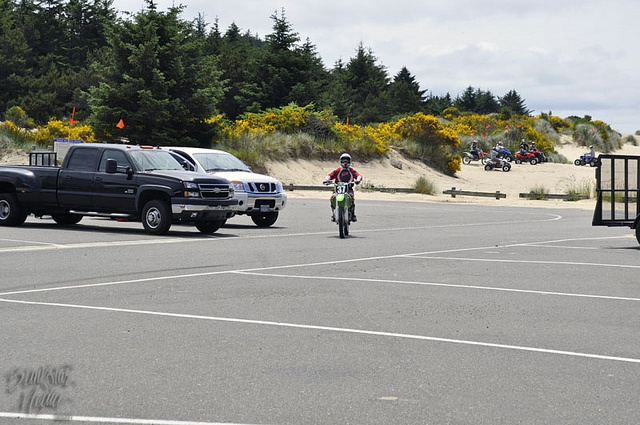Describe the objects in this image and their specific colors. I can see truck in darkgreen, black, gray, and darkgray tones, truck in darkgreen, white, black, darkgray, and gray tones, car in darkgreen, white, black, darkgray, and gray tones, motorcycle in darkgreen, black, gray, darkgray, and lightgray tones, and people in darkgreen, black, gray, darkgray, and lightgray tones in this image. 